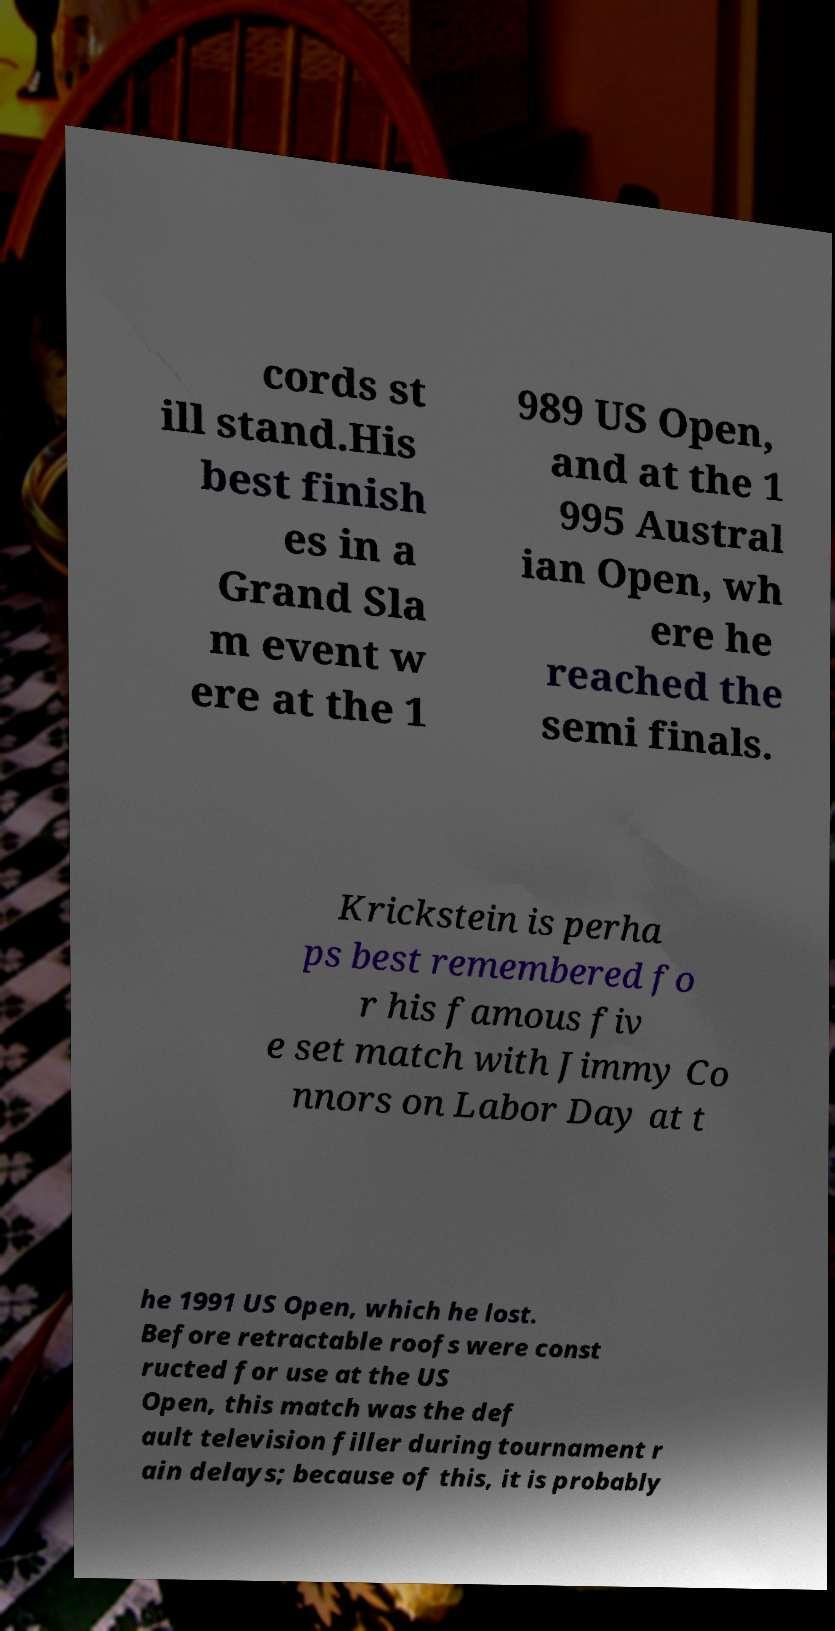For documentation purposes, I need the text within this image transcribed. Could you provide that? cords st ill stand.His best finish es in a Grand Sla m event w ere at the 1 989 US Open, and at the 1 995 Austral ian Open, wh ere he reached the semi finals. Krickstein is perha ps best remembered fo r his famous fiv e set match with Jimmy Co nnors on Labor Day at t he 1991 US Open, which he lost. Before retractable roofs were const ructed for use at the US Open, this match was the def ault television filler during tournament r ain delays; because of this, it is probably 